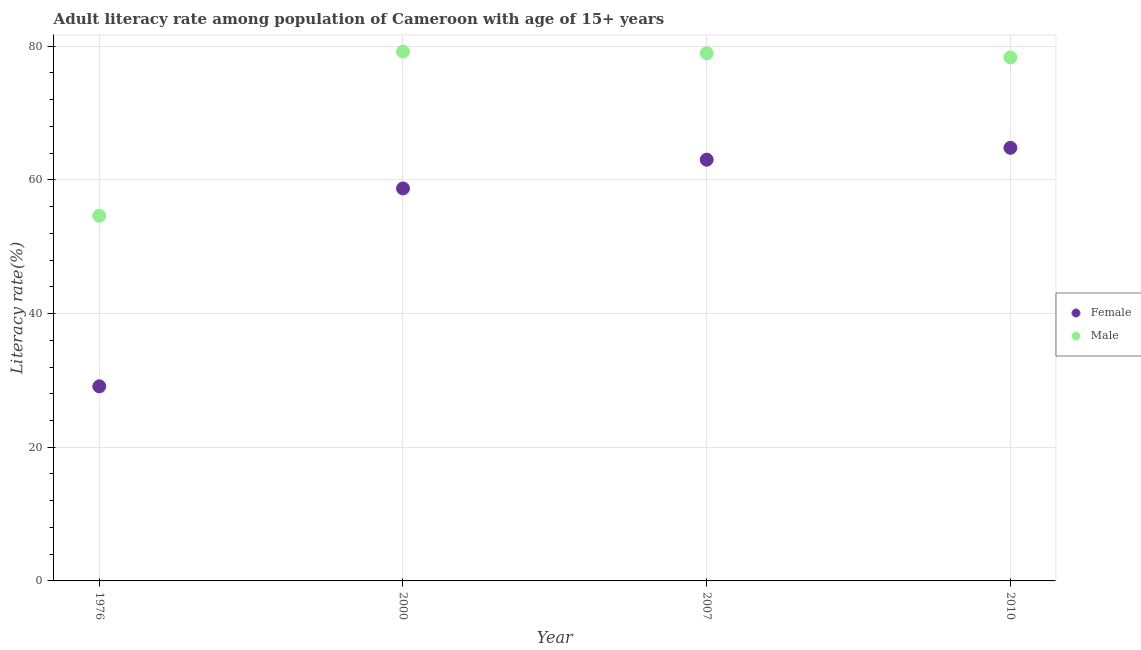How many different coloured dotlines are there?
Keep it short and to the point. 2. Is the number of dotlines equal to the number of legend labels?
Your answer should be compact. Yes. What is the female adult literacy rate in 2007?
Your response must be concise. 63.02. Across all years, what is the maximum male adult literacy rate?
Offer a terse response. 79.19. Across all years, what is the minimum female adult literacy rate?
Ensure brevity in your answer.  29.12. In which year was the female adult literacy rate maximum?
Keep it short and to the point. 2010. In which year was the male adult literacy rate minimum?
Offer a terse response. 1976. What is the total male adult literacy rate in the graph?
Ensure brevity in your answer.  291.1. What is the difference between the female adult literacy rate in 1976 and that in 2010?
Provide a succinct answer. -35.68. What is the difference between the male adult literacy rate in 2007 and the female adult literacy rate in 2000?
Make the answer very short. 20.23. What is the average female adult literacy rate per year?
Ensure brevity in your answer.  53.91. In the year 2007, what is the difference between the male adult literacy rate and female adult literacy rate?
Provide a short and direct response. 15.93. In how many years, is the female adult literacy rate greater than 36 %?
Offer a very short reply. 3. What is the ratio of the female adult literacy rate in 2000 to that in 2010?
Your response must be concise. 0.91. Is the male adult literacy rate in 2000 less than that in 2010?
Your response must be concise. No. What is the difference between the highest and the second highest female adult literacy rate?
Ensure brevity in your answer.  1.78. What is the difference between the highest and the lowest male adult literacy rate?
Offer a very short reply. 24.56. Is the male adult literacy rate strictly greater than the female adult literacy rate over the years?
Offer a very short reply. Yes. How many dotlines are there?
Provide a short and direct response. 2. How many years are there in the graph?
Provide a succinct answer. 4. Are the values on the major ticks of Y-axis written in scientific E-notation?
Ensure brevity in your answer.  No. Does the graph contain grids?
Provide a succinct answer. Yes. How many legend labels are there?
Ensure brevity in your answer.  2. How are the legend labels stacked?
Offer a very short reply. Vertical. What is the title of the graph?
Give a very brief answer. Adult literacy rate among population of Cameroon with age of 15+ years. What is the label or title of the X-axis?
Provide a short and direct response. Year. What is the label or title of the Y-axis?
Your answer should be compact. Literacy rate(%). What is the Literacy rate(%) in Female in 1976?
Keep it short and to the point. 29.12. What is the Literacy rate(%) in Male in 1976?
Your response must be concise. 54.63. What is the Literacy rate(%) of Female in 2000?
Your response must be concise. 58.72. What is the Literacy rate(%) in Male in 2000?
Provide a succinct answer. 79.19. What is the Literacy rate(%) in Female in 2007?
Your response must be concise. 63.02. What is the Literacy rate(%) in Male in 2007?
Keep it short and to the point. 78.95. What is the Literacy rate(%) in Female in 2010?
Keep it short and to the point. 64.8. What is the Literacy rate(%) in Male in 2010?
Offer a very short reply. 78.33. Across all years, what is the maximum Literacy rate(%) in Female?
Keep it short and to the point. 64.8. Across all years, what is the maximum Literacy rate(%) in Male?
Provide a short and direct response. 79.19. Across all years, what is the minimum Literacy rate(%) of Female?
Make the answer very short. 29.12. Across all years, what is the minimum Literacy rate(%) in Male?
Your response must be concise. 54.63. What is the total Literacy rate(%) of Female in the graph?
Your response must be concise. 215.66. What is the total Literacy rate(%) in Male in the graph?
Keep it short and to the point. 291.1. What is the difference between the Literacy rate(%) of Female in 1976 and that in 2000?
Your answer should be very brief. -29.61. What is the difference between the Literacy rate(%) of Male in 1976 and that in 2000?
Make the answer very short. -24.56. What is the difference between the Literacy rate(%) of Female in 1976 and that in 2007?
Offer a terse response. -33.91. What is the difference between the Literacy rate(%) of Male in 1976 and that in 2007?
Make the answer very short. -24.32. What is the difference between the Literacy rate(%) in Female in 1976 and that in 2010?
Offer a very short reply. -35.68. What is the difference between the Literacy rate(%) in Male in 1976 and that in 2010?
Provide a short and direct response. -23.7. What is the difference between the Literacy rate(%) in Female in 2000 and that in 2007?
Your answer should be compact. -4.3. What is the difference between the Literacy rate(%) of Male in 2000 and that in 2007?
Your answer should be very brief. 0.24. What is the difference between the Literacy rate(%) in Female in 2000 and that in 2010?
Give a very brief answer. -6.08. What is the difference between the Literacy rate(%) in Male in 2000 and that in 2010?
Give a very brief answer. 0.87. What is the difference between the Literacy rate(%) in Female in 2007 and that in 2010?
Your answer should be very brief. -1.78. What is the difference between the Literacy rate(%) in Male in 2007 and that in 2010?
Your response must be concise. 0.62. What is the difference between the Literacy rate(%) of Female in 1976 and the Literacy rate(%) of Male in 2000?
Offer a terse response. -50.08. What is the difference between the Literacy rate(%) in Female in 1976 and the Literacy rate(%) in Male in 2007?
Provide a short and direct response. -49.83. What is the difference between the Literacy rate(%) of Female in 1976 and the Literacy rate(%) of Male in 2010?
Provide a succinct answer. -49.21. What is the difference between the Literacy rate(%) of Female in 2000 and the Literacy rate(%) of Male in 2007?
Your answer should be very brief. -20.23. What is the difference between the Literacy rate(%) of Female in 2000 and the Literacy rate(%) of Male in 2010?
Provide a short and direct response. -19.61. What is the difference between the Literacy rate(%) of Female in 2007 and the Literacy rate(%) of Male in 2010?
Offer a very short reply. -15.31. What is the average Literacy rate(%) of Female per year?
Offer a very short reply. 53.91. What is the average Literacy rate(%) of Male per year?
Offer a very short reply. 72.78. In the year 1976, what is the difference between the Literacy rate(%) in Female and Literacy rate(%) in Male?
Keep it short and to the point. -25.51. In the year 2000, what is the difference between the Literacy rate(%) of Female and Literacy rate(%) of Male?
Offer a terse response. -20.47. In the year 2007, what is the difference between the Literacy rate(%) of Female and Literacy rate(%) of Male?
Give a very brief answer. -15.93. In the year 2010, what is the difference between the Literacy rate(%) in Female and Literacy rate(%) in Male?
Your answer should be very brief. -13.53. What is the ratio of the Literacy rate(%) in Female in 1976 to that in 2000?
Provide a succinct answer. 0.5. What is the ratio of the Literacy rate(%) of Male in 1976 to that in 2000?
Your answer should be very brief. 0.69. What is the ratio of the Literacy rate(%) of Female in 1976 to that in 2007?
Make the answer very short. 0.46. What is the ratio of the Literacy rate(%) of Male in 1976 to that in 2007?
Make the answer very short. 0.69. What is the ratio of the Literacy rate(%) in Female in 1976 to that in 2010?
Give a very brief answer. 0.45. What is the ratio of the Literacy rate(%) of Male in 1976 to that in 2010?
Offer a terse response. 0.7. What is the ratio of the Literacy rate(%) in Female in 2000 to that in 2007?
Your response must be concise. 0.93. What is the ratio of the Literacy rate(%) of Female in 2000 to that in 2010?
Your response must be concise. 0.91. What is the ratio of the Literacy rate(%) in Male in 2000 to that in 2010?
Offer a very short reply. 1.01. What is the ratio of the Literacy rate(%) of Female in 2007 to that in 2010?
Your response must be concise. 0.97. What is the ratio of the Literacy rate(%) in Male in 2007 to that in 2010?
Provide a short and direct response. 1.01. What is the difference between the highest and the second highest Literacy rate(%) of Female?
Provide a succinct answer. 1.78. What is the difference between the highest and the second highest Literacy rate(%) in Male?
Provide a succinct answer. 0.24. What is the difference between the highest and the lowest Literacy rate(%) in Female?
Ensure brevity in your answer.  35.68. What is the difference between the highest and the lowest Literacy rate(%) of Male?
Provide a short and direct response. 24.56. 